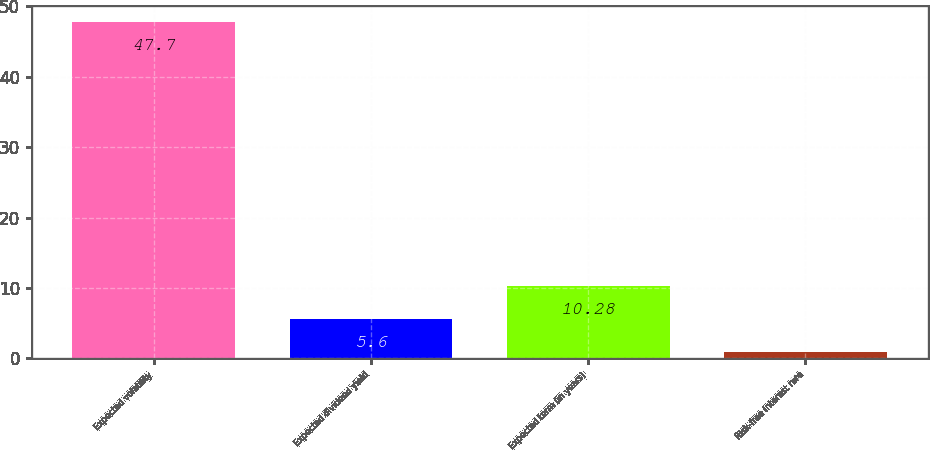<chart> <loc_0><loc_0><loc_500><loc_500><bar_chart><fcel>Expected volatility<fcel>Expected dividend yield<fcel>Expected term (in years)<fcel>Risk-free interest rate<nl><fcel>47.7<fcel>5.6<fcel>10.28<fcel>0.92<nl></chart> 